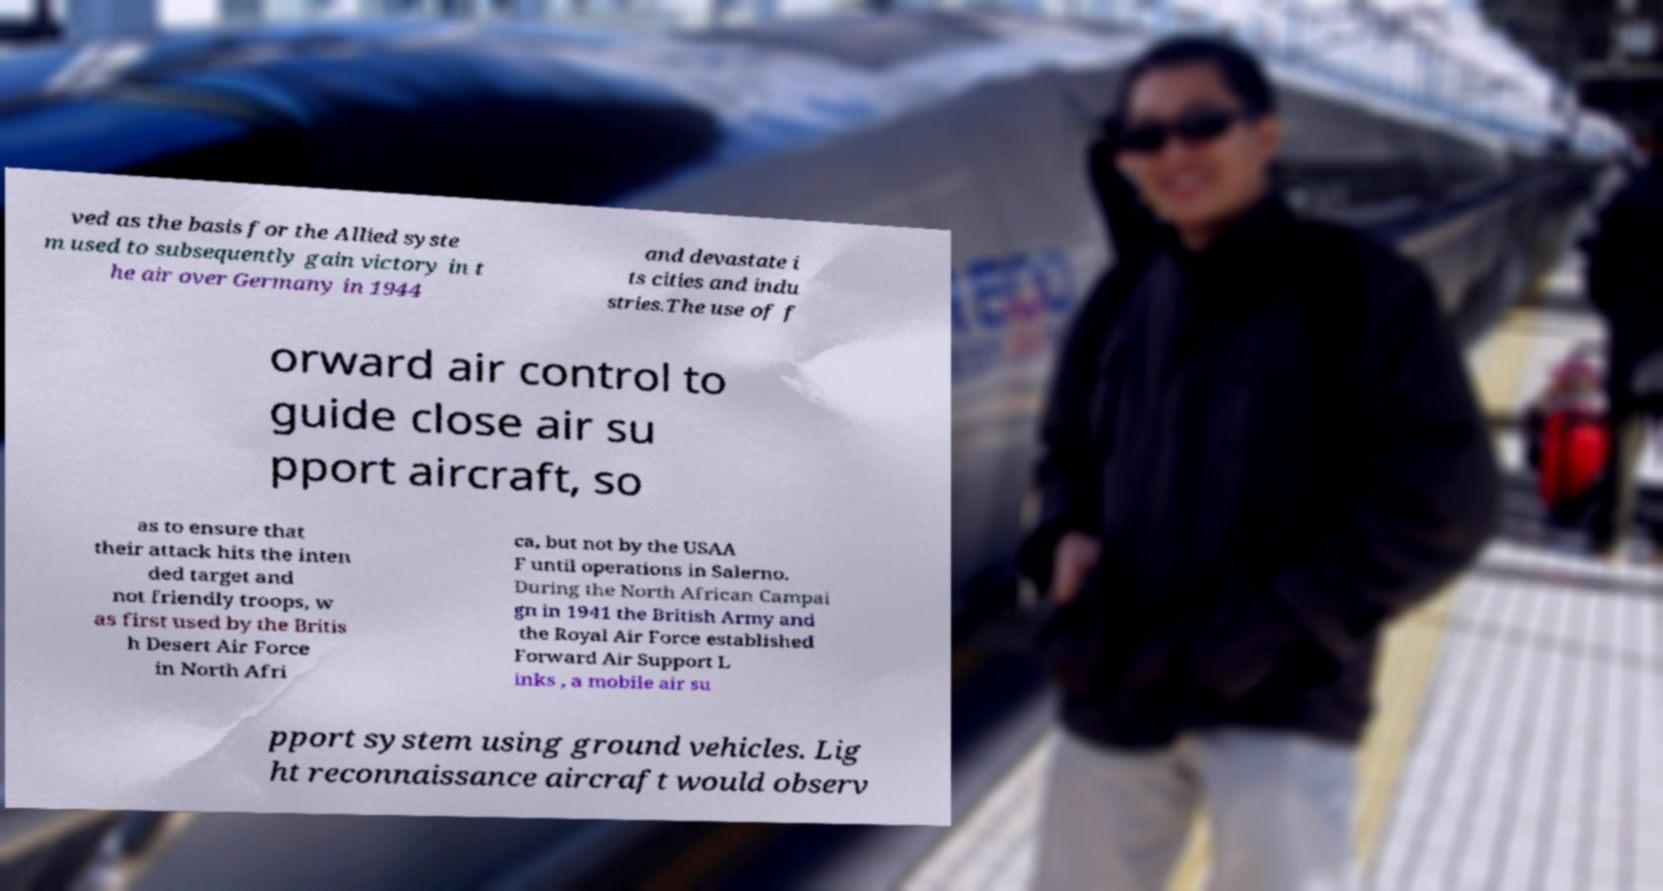Can you accurately transcribe the text from the provided image for me? ved as the basis for the Allied syste m used to subsequently gain victory in t he air over Germany in 1944 and devastate i ts cities and indu stries.The use of f orward air control to guide close air su pport aircraft, so as to ensure that their attack hits the inten ded target and not friendly troops, w as first used by the Britis h Desert Air Force in North Afri ca, but not by the USAA F until operations in Salerno. During the North African Campai gn in 1941 the British Army and the Royal Air Force established Forward Air Support L inks , a mobile air su pport system using ground vehicles. Lig ht reconnaissance aircraft would observ 